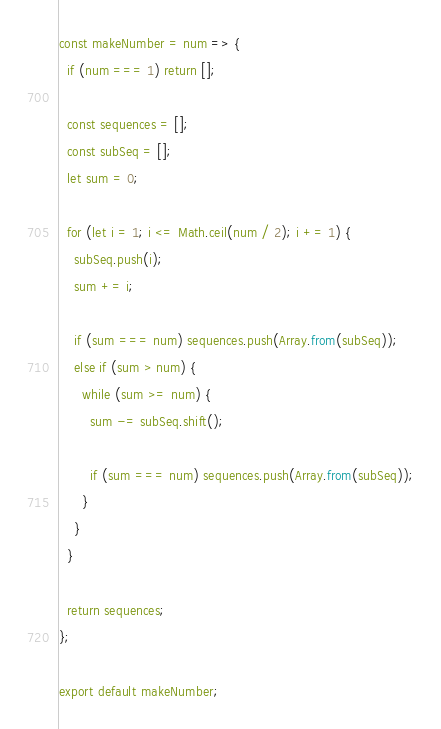<code> <loc_0><loc_0><loc_500><loc_500><_JavaScript_>const makeNumber = num => {
  if (num === 1) return [];

  const sequences = [];
  const subSeq = [];
  let sum = 0;

  for (let i = 1; i <= Math.ceil(num / 2); i += 1) {
    subSeq.push(i);
    sum += i;

    if (sum === num) sequences.push(Array.from(subSeq));
    else if (sum > num) {
      while (sum >= num) {
        sum -= subSeq.shift();

        if (sum === num) sequences.push(Array.from(subSeq));
      }
    }
  }

  return sequences;
};

export default makeNumber;
</code> 